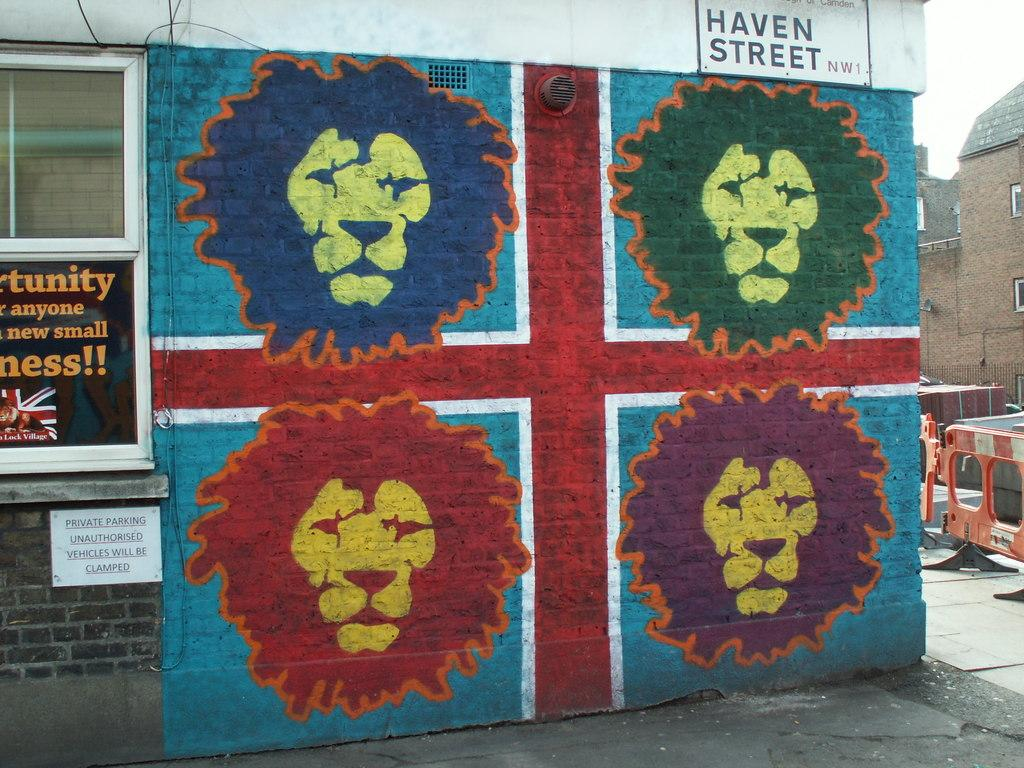<image>
Share a concise interpretation of the image provided. some photos of lions with Haven Street above them 